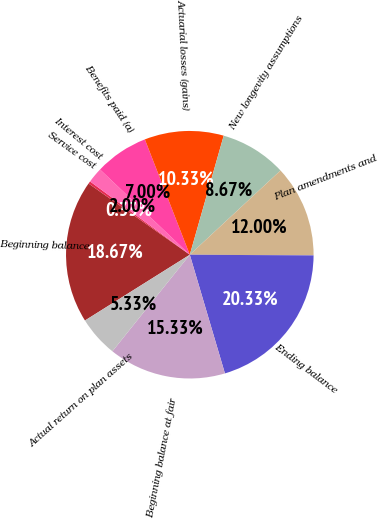Convert chart. <chart><loc_0><loc_0><loc_500><loc_500><pie_chart><fcel>Beginning balance<fcel>Service cost<fcel>Interest cost<fcel>Benefits paid (a)<fcel>Actuarial losses (gains)<fcel>New longevity assumptions<fcel>Plan amendments and<fcel>Ending balance<fcel>Beginning balance at fair<fcel>Actual return on plan assets<nl><fcel>18.67%<fcel>0.33%<fcel>2.0%<fcel>7.0%<fcel>10.33%<fcel>8.67%<fcel>12.0%<fcel>20.33%<fcel>15.33%<fcel>5.33%<nl></chart> 